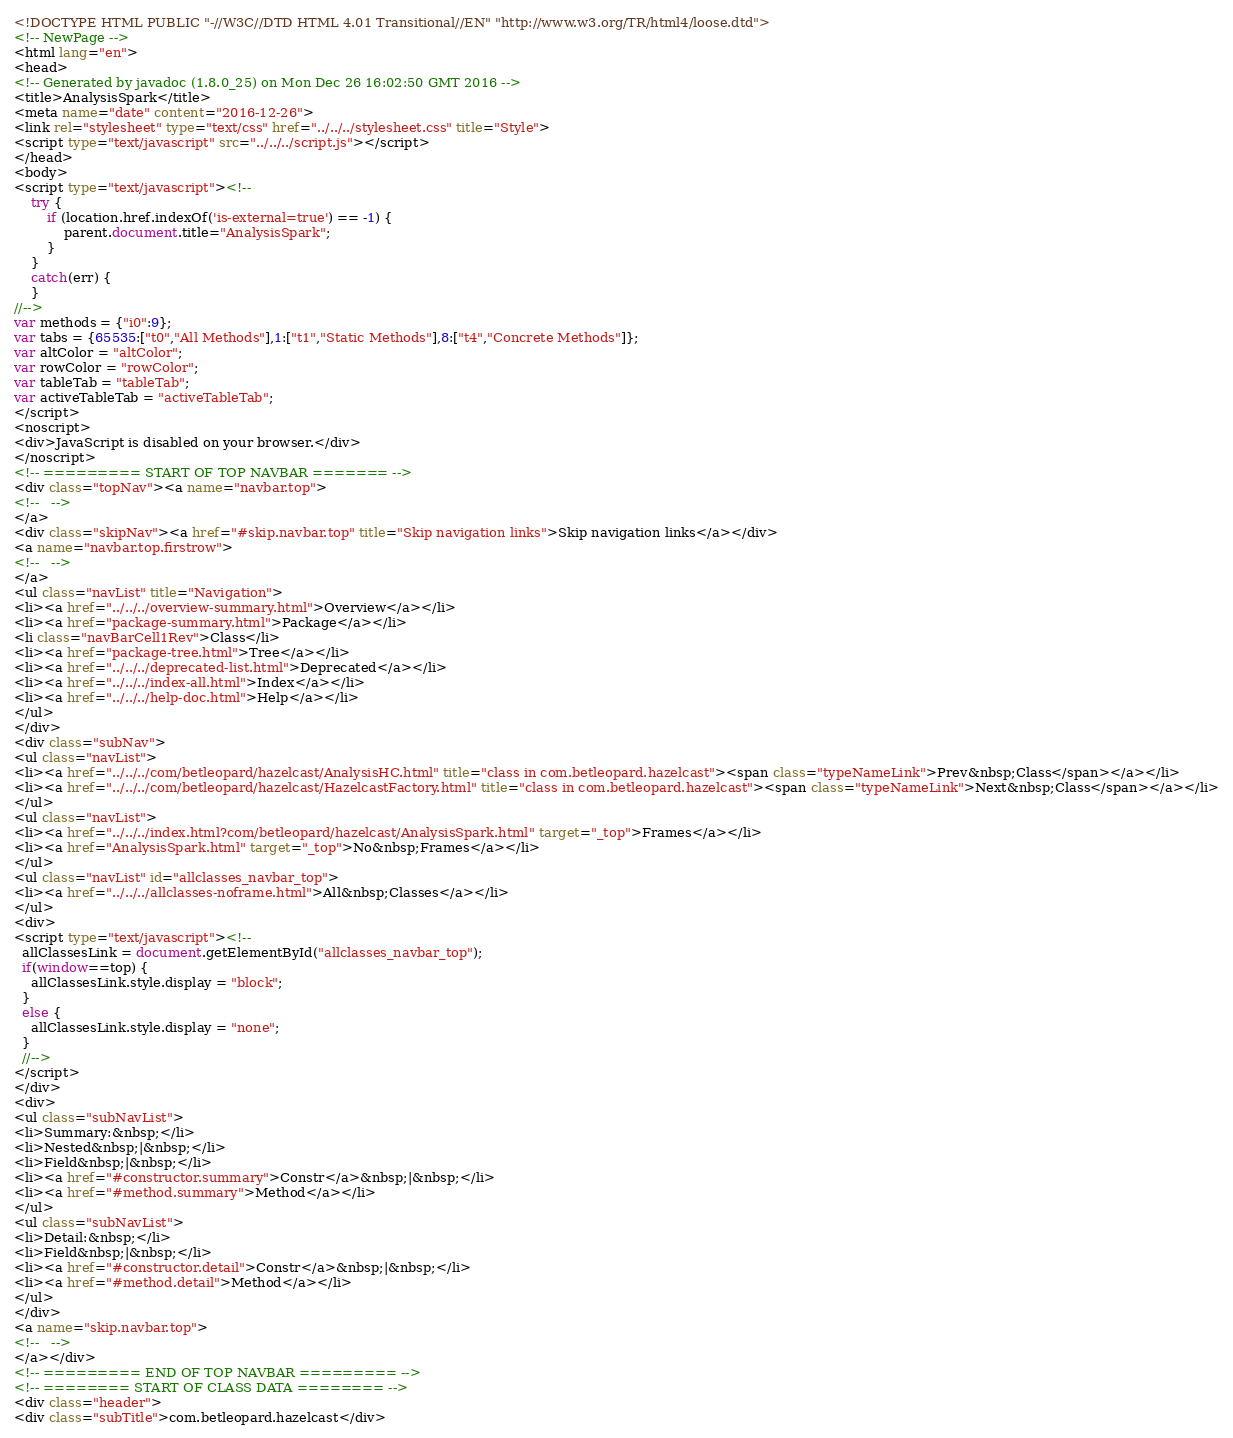<code> <loc_0><loc_0><loc_500><loc_500><_HTML_><!DOCTYPE HTML PUBLIC "-//W3C//DTD HTML 4.01 Transitional//EN" "http://www.w3.org/TR/html4/loose.dtd">
<!-- NewPage -->
<html lang="en">
<head>
<!-- Generated by javadoc (1.8.0_25) on Mon Dec 26 16:02:50 GMT 2016 -->
<title>AnalysisSpark</title>
<meta name="date" content="2016-12-26">
<link rel="stylesheet" type="text/css" href="../../../stylesheet.css" title="Style">
<script type="text/javascript" src="../../../script.js"></script>
</head>
<body>
<script type="text/javascript"><!--
    try {
        if (location.href.indexOf('is-external=true') == -1) {
            parent.document.title="AnalysisSpark";
        }
    }
    catch(err) {
    }
//-->
var methods = {"i0":9};
var tabs = {65535:["t0","All Methods"],1:["t1","Static Methods"],8:["t4","Concrete Methods"]};
var altColor = "altColor";
var rowColor = "rowColor";
var tableTab = "tableTab";
var activeTableTab = "activeTableTab";
</script>
<noscript>
<div>JavaScript is disabled on your browser.</div>
</noscript>
<!-- ========= START OF TOP NAVBAR ======= -->
<div class="topNav"><a name="navbar.top">
<!--   -->
</a>
<div class="skipNav"><a href="#skip.navbar.top" title="Skip navigation links">Skip navigation links</a></div>
<a name="navbar.top.firstrow">
<!--   -->
</a>
<ul class="navList" title="Navigation">
<li><a href="../../../overview-summary.html">Overview</a></li>
<li><a href="package-summary.html">Package</a></li>
<li class="navBarCell1Rev">Class</li>
<li><a href="package-tree.html">Tree</a></li>
<li><a href="../../../deprecated-list.html">Deprecated</a></li>
<li><a href="../../../index-all.html">Index</a></li>
<li><a href="../../../help-doc.html">Help</a></li>
</ul>
</div>
<div class="subNav">
<ul class="navList">
<li><a href="../../../com/betleopard/hazelcast/AnalysisHC.html" title="class in com.betleopard.hazelcast"><span class="typeNameLink">Prev&nbsp;Class</span></a></li>
<li><a href="../../../com/betleopard/hazelcast/HazelcastFactory.html" title="class in com.betleopard.hazelcast"><span class="typeNameLink">Next&nbsp;Class</span></a></li>
</ul>
<ul class="navList">
<li><a href="../../../index.html?com/betleopard/hazelcast/AnalysisSpark.html" target="_top">Frames</a></li>
<li><a href="AnalysisSpark.html" target="_top">No&nbsp;Frames</a></li>
</ul>
<ul class="navList" id="allclasses_navbar_top">
<li><a href="../../../allclasses-noframe.html">All&nbsp;Classes</a></li>
</ul>
<div>
<script type="text/javascript"><!--
  allClassesLink = document.getElementById("allclasses_navbar_top");
  if(window==top) {
    allClassesLink.style.display = "block";
  }
  else {
    allClassesLink.style.display = "none";
  }
  //-->
</script>
</div>
<div>
<ul class="subNavList">
<li>Summary:&nbsp;</li>
<li>Nested&nbsp;|&nbsp;</li>
<li>Field&nbsp;|&nbsp;</li>
<li><a href="#constructor.summary">Constr</a>&nbsp;|&nbsp;</li>
<li><a href="#method.summary">Method</a></li>
</ul>
<ul class="subNavList">
<li>Detail:&nbsp;</li>
<li>Field&nbsp;|&nbsp;</li>
<li><a href="#constructor.detail">Constr</a>&nbsp;|&nbsp;</li>
<li><a href="#method.detail">Method</a></li>
</ul>
</div>
<a name="skip.navbar.top">
<!--   -->
</a></div>
<!-- ========= END OF TOP NAVBAR ========= -->
<!-- ======== START OF CLASS DATA ======== -->
<div class="header">
<div class="subTitle">com.betleopard.hazelcast</div></code> 